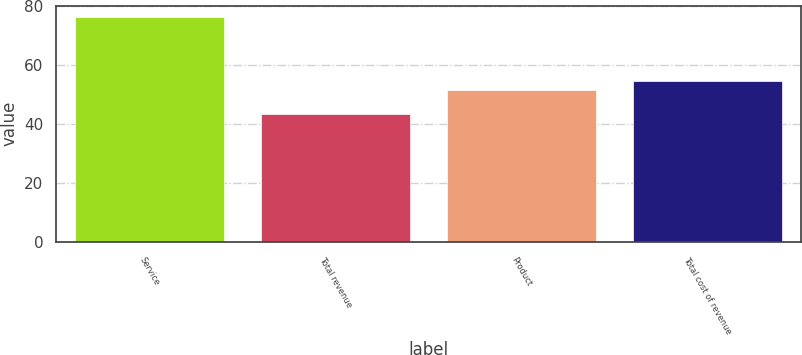Convert chart. <chart><loc_0><loc_0><loc_500><loc_500><bar_chart><fcel>Service<fcel>Total revenue<fcel>Product<fcel>Total cost of revenue<nl><fcel>76.4<fcel>43.4<fcel>51.5<fcel>54.8<nl></chart> 